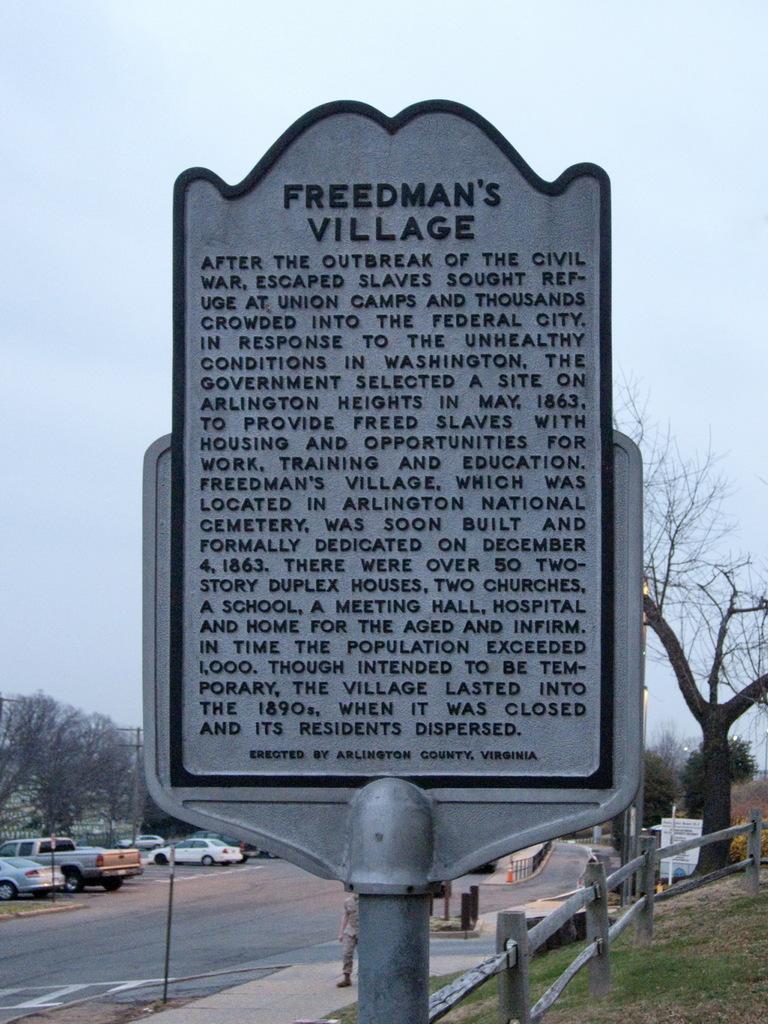How would you summarize this image in a sentence or two? In the image we can see there are cars parked on the road and there is a hoarding. There are trees and people standing on footpath. There is a clear sky. 